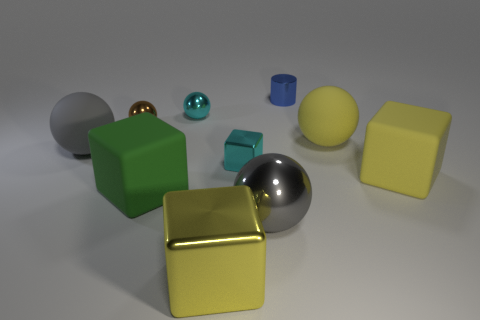What can the arrangement of these shapes tell us about perspective and depth? The placement of these shapes creates a sense of depth and three-dimensionality. The larger objects are positioned in the foreground, while smaller ones appear towards the back, enhancing the perspective. The variation in size and overlap of the shapes helps convey the spatial layout of the scene, offering cues to the viewer about the relative distance of each object from their vantage point. 